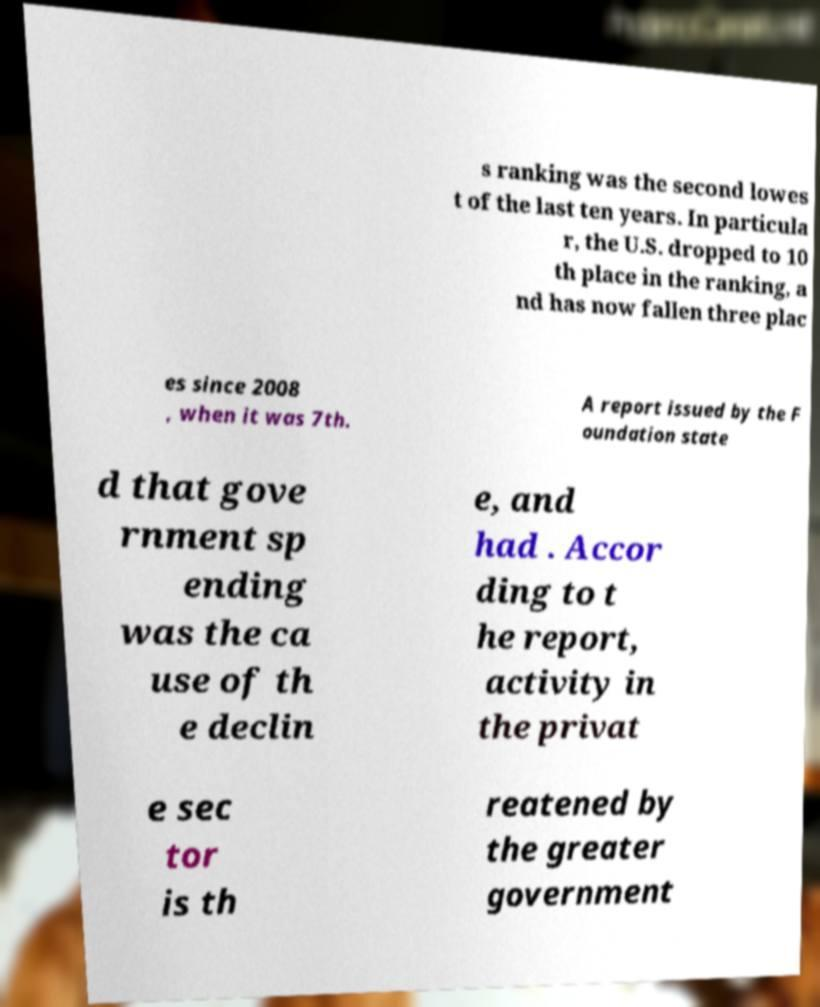Can you accurately transcribe the text from the provided image for me? s ranking was the second lowes t of the last ten years. In particula r, the U.S. dropped to 10 th place in the ranking, a nd has now fallen three plac es since 2008 , when it was 7th. A report issued by the F oundation state d that gove rnment sp ending was the ca use of th e declin e, and had . Accor ding to t he report, activity in the privat e sec tor is th reatened by the greater government 